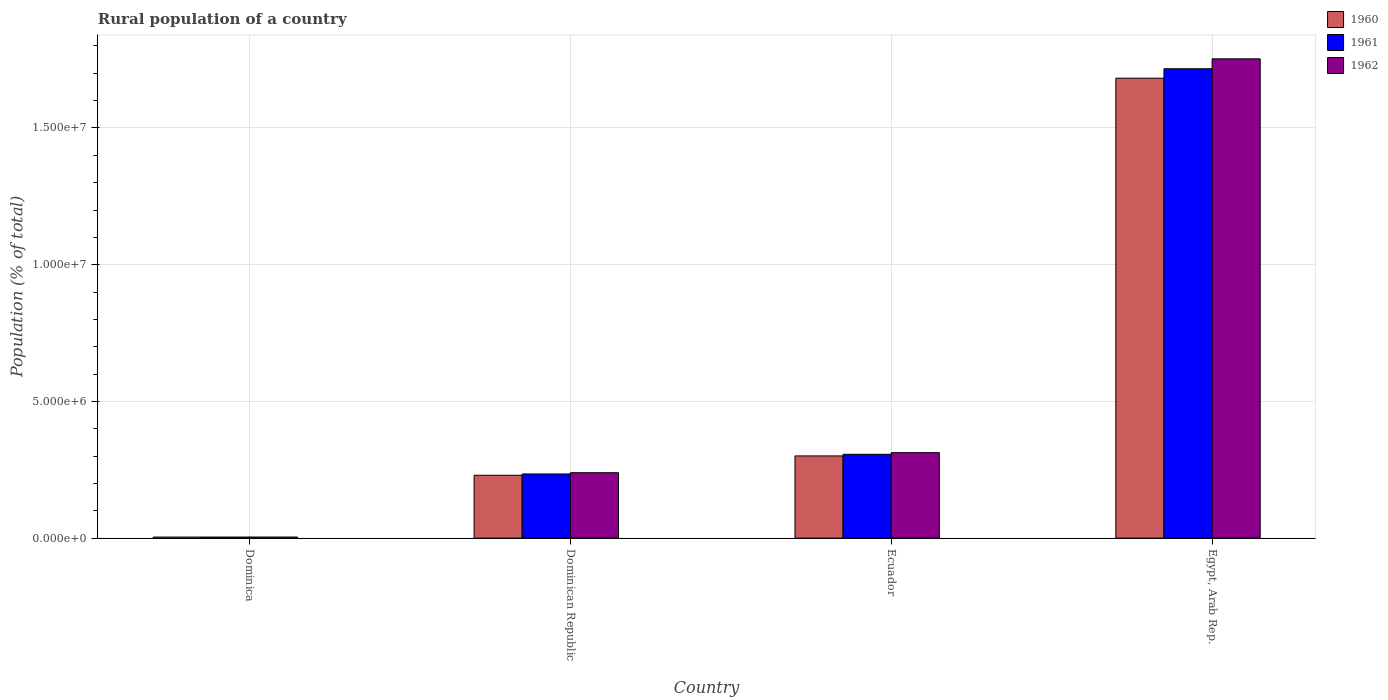How many different coloured bars are there?
Offer a very short reply. 3. How many groups of bars are there?
Keep it short and to the point. 4. Are the number of bars per tick equal to the number of legend labels?
Provide a succinct answer. Yes. What is the label of the 3rd group of bars from the left?
Your response must be concise. Ecuador. In how many cases, is the number of bars for a given country not equal to the number of legend labels?
Your answer should be very brief. 0. What is the rural population in 1962 in Ecuador?
Your response must be concise. 3.13e+06. Across all countries, what is the maximum rural population in 1960?
Offer a very short reply. 1.68e+07. Across all countries, what is the minimum rural population in 1962?
Your answer should be compact. 3.84e+04. In which country was the rural population in 1960 maximum?
Keep it short and to the point. Egypt, Arab Rep. In which country was the rural population in 1961 minimum?
Offer a terse response. Dominica. What is the total rural population in 1960 in the graph?
Give a very brief answer. 2.22e+07. What is the difference between the rural population in 1961 in Dominica and that in Egypt, Arab Rep.?
Your answer should be very brief. -1.71e+07. What is the difference between the rural population in 1962 in Ecuador and the rural population in 1960 in Dominican Republic?
Keep it short and to the point. 8.27e+05. What is the average rural population in 1960 per country?
Keep it short and to the point. 5.54e+06. What is the difference between the rural population of/in 1962 and rural population of/in 1960 in Dominican Republic?
Offer a very short reply. 9.29e+04. What is the ratio of the rural population in 1960 in Ecuador to that in Egypt, Arab Rep.?
Your answer should be very brief. 0.18. What is the difference between the highest and the second highest rural population in 1962?
Provide a short and direct response. 1.44e+07. What is the difference between the highest and the lowest rural population in 1961?
Offer a terse response. 1.71e+07. In how many countries, is the rural population in 1961 greater than the average rural population in 1961 taken over all countries?
Your response must be concise. 1. Is the sum of the rural population in 1962 in Dominica and Egypt, Arab Rep. greater than the maximum rural population in 1960 across all countries?
Offer a terse response. Yes. What does the 2nd bar from the left in Egypt, Arab Rep. represents?
Your answer should be compact. 1961. What does the 3rd bar from the right in Ecuador represents?
Offer a very short reply. 1960. Is it the case that in every country, the sum of the rural population in 1962 and rural population in 1960 is greater than the rural population in 1961?
Provide a succinct answer. Yes. Are the values on the major ticks of Y-axis written in scientific E-notation?
Offer a very short reply. Yes. Does the graph contain any zero values?
Provide a succinct answer. No. Where does the legend appear in the graph?
Provide a short and direct response. Top right. How are the legend labels stacked?
Your answer should be compact. Vertical. What is the title of the graph?
Provide a short and direct response. Rural population of a country. Does "1999" appear as one of the legend labels in the graph?
Make the answer very short. No. What is the label or title of the X-axis?
Offer a terse response. Country. What is the label or title of the Y-axis?
Your answer should be compact. Population (% of total). What is the Population (% of total) of 1960 in Dominica?
Give a very brief answer. 3.73e+04. What is the Population (% of total) of 1961 in Dominica?
Keep it short and to the point. 3.79e+04. What is the Population (% of total) in 1962 in Dominica?
Keep it short and to the point. 3.84e+04. What is the Population (% of total) of 1960 in Dominican Republic?
Give a very brief answer. 2.30e+06. What is the Population (% of total) in 1961 in Dominican Republic?
Offer a very short reply. 2.35e+06. What is the Population (% of total) of 1962 in Dominican Republic?
Keep it short and to the point. 2.39e+06. What is the Population (% of total) of 1960 in Ecuador?
Give a very brief answer. 3.01e+06. What is the Population (% of total) of 1961 in Ecuador?
Provide a succinct answer. 3.06e+06. What is the Population (% of total) in 1962 in Ecuador?
Your response must be concise. 3.13e+06. What is the Population (% of total) in 1960 in Egypt, Arab Rep.?
Make the answer very short. 1.68e+07. What is the Population (% of total) of 1961 in Egypt, Arab Rep.?
Provide a short and direct response. 1.72e+07. What is the Population (% of total) of 1962 in Egypt, Arab Rep.?
Offer a very short reply. 1.75e+07. Across all countries, what is the maximum Population (% of total) of 1960?
Your response must be concise. 1.68e+07. Across all countries, what is the maximum Population (% of total) in 1961?
Give a very brief answer. 1.72e+07. Across all countries, what is the maximum Population (% of total) of 1962?
Your answer should be compact. 1.75e+07. Across all countries, what is the minimum Population (% of total) of 1960?
Keep it short and to the point. 3.73e+04. Across all countries, what is the minimum Population (% of total) of 1961?
Provide a succinct answer. 3.79e+04. Across all countries, what is the minimum Population (% of total) of 1962?
Your response must be concise. 3.84e+04. What is the total Population (% of total) in 1960 in the graph?
Make the answer very short. 2.22e+07. What is the total Population (% of total) of 1961 in the graph?
Keep it short and to the point. 2.26e+07. What is the total Population (% of total) in 1962 in the graph?
Give a very brief answer. 2.31e+07. What is the difference between the Population (% of total) of 1960 in Dominica and that in Dominican Republic?
Offer a terse response. -2.26e+06. What is the difference between the Population (% of total) in 1961 in Dominica and that in Dominican Republic?
Ensure brevity in your answer.  -2.31e+06. What is the difference between the Population (% of total) of 1962 in Dominica and that in Dominican Republic?
Make the answer very short. -2.35e+06. What is the difference between the Population (% of total) in 1960 in Dominica and that in Ecuador?
Offer a very short reply. -2.97e+06. What is the difference between the Population (% of total) of 1961 in Dominica and that in Ecuador?
Keep it short and to the point. -3.03e+06. What is the difference between the Population (% of total) in 1962 in Dominica and that in Ecuador?
Provide a succinct answer. -3.09e+06. What is the difference between the Population (% of total) of 1960 in Dominica and that in Egypt, Arab Rep.?
Your answer should be compact. -1.68e+07. What is the difference between the Population (% of total) in 1961 in Dominica and that in Egypt, Arab Rep.?
Your response must be concise. -1.71e+07. What is the difference between the Population (% of total) of 1962 in Dominica and that in Egypt, Arab Rep.?
Provide a succinct answer. -1.75e+07. What is the difference between the Population (% of total) of 1960 in Dominican Republic and that in Ecuador?
Your response must be concise. -7.07e+05. What is the difference between the Population (% of total) in 1961 in Dominican Republic and that in Ecuador?
Offer a terse response. -7.19e+05. What is the difference between the Population (% of total) in 1962 in Dominican Republic and that in Ecuador?
Provide a short and direct response. -7.34e+05. What is the difference between the Population (% of total) of 1960 in Dominican Republic and that in Egypt, Arab Rep.?
Your response must be concise. -1.45e+07. What is the difference between the Population (% of total) in 1961 in Dominican Republic and that in Egypt, Arab Rep.?
Offer a very short reply. -1.48e+07. What is the difference between the Population (% of total) of 1962 in Dominican Republic and that in Egypt, Arab Rep.?
Offer a very short reply. -1.51e+07. What is the difference between the Population (% of total) in 1960 in Ecuador and that in Egypt, Arab Rep.?
Offer a very short reply. -1.38e+07. What is the difference between the Population (% of total) of 1961 in Ecuador and that in Egypt, Arab Rep.?
Your answer should be very brief. -1.41e+07. What is the difference between the Population (% of total) of 1962 in Ecuador and that in Egypt, Arab Rep.?
Provide a succinct answer. -1.44e+07. What is the difference between the Population (% of total) of 1960 in Dominica and the Population (% of total) of 1961 in Dominican Republic?
Offer a terse response. -2.31e+06. What is the difference between the Population (% of total) of 1960 in Dominica and the Population (% of total) of 1962 in Dominican Republic?
Offer a terse response. -2.35e+06. What is the difference between the Population (% of total) of 1961 in Dominica and the Population (% of total) of 1962 in Dominican Republic?
Provide a succinct answer. -2.35e+06. What is the difference between the Population (% of total) in 1960 in Dominica and the Population (% of total) in 1961 in Ecuador?
Keep it short and to the point. -3.03e+06. What is the difference between the Population (% of total) of 1960 in Dominica and the Population (% of total) of 1962 in Ecuador?
Offer a very short reply. -3.09e+06. What is the difference between the Population (% of total) in 1961 in Dominica and the Population (% of total) in 1962 in Ecuador?
Give a very brief answer. -3.09e+06. What is the difference between the Population (% of total) in 1960 in Dominica and the Population (% of total) in 1961 in Egypt, Arab Rep.?
Make the answer very short. -1.71e+07. What is the difference between the Population (% of total) in 1960 in Dominica and the Population (% of total) in 1962 in Egypt, Arab Rep.?
Provide a succinct answer. -1.75e+07. What is the difference between the Population (% of total) of 1961 in Dominica and the Population (% of total) of 1962 in Egypt, Arab Rep.?
Provide a short and direct response. -1.75e+07. What is the difference between the Population (% of total) of 1960 in Dominican Republic and the Population (% of total) of 1961 in Ecuador?
Your response must be concise. -7.67e+05. What is the difference between the Population (% of total) in 1960 in Dominican Republic and the Population (% of total) in 1962 in Ecuador?
Your answer should be compact. -8.27e+05. What is the difference between the Population (% of total) of 1961 in Dominican Republic and the Population (% of total) of 1962 in Ecuador?
Keep it short and to the point. -7.80e+05. What is the difference between the Population (% of total) in 1960 in Dominican Republic and the Population (% of total) in 1961 in Egypt, Arab Rep.?
Keep it short and to the point. -1.49e+07. What is the difference between the Population (% of total) of 1960 in Dominican Republic and the Population (% of total) of 1962 in Egypt, Arab Rep.?
Make the answer very short. -1.52e+07. What is the difference between the Population (% of total) of 1961 in Dominican Republic and the Population (% of total) of 1962 in Egypt, Arab Rep.?
Provide a succinct answer. -1.52e+07. What is the difference between the Population (% of total) of 1960 in Ecuador and the Population (% of total) of 1961 in Egypt, Arab Rep.?
Give a very brief answer. -1.42e+07. What is the difference between the Population (% of total) of 1960 in Ecuador and the Population (% of total) of 1962 in Egypt, Arab Rep.?
Offer a very short reply. -1.45e+07. What is the difference between the Population (% of total) of 1961 in Ecuador and the Population (% of total) of 1962 in Egypt, Arab Rep.?
Make the answer very short. -1.45e+07. What is the average Population (% of total) in 1960 per country?
Make the answer very short. 5.54e+06. What is the average Population (% of total) of 1961 per country?
Provide a short and direct response. 5.65e+06. What is the average Population (% of total) in 1962 per country?
Offer a very short reply. 5.77e+06. What is the difference between the Population (% of total) in 1960 and Population (% of total) in 1961 in Dominica?
Your answer should be compact. -593. What is the difference between the Population (% of total) in 1960 and Population (% of total) in 1962 in Dominica?
Your answer should be very brief. -1141. What is the difference between the Population (% of total) in 1961 and Population (% of total) in 1962 in Dominica?
Your response must be concise. -548. What is the difference between the Population (% of total) in 1960 and Population (% of total) in 1961 in Dominican Republic?
Offer a very short reply. -4.73e+04. What is the difference between the Population (% of total) of 1960 and Population (% of total) of 1962 in Dominican Republic?
Ensure brevity in your answer.  -9.29e+04. What is the difference between the Population (% of total) in 1961 and Population (% of total) in 1962 in Dominican Republic?
Offer a terse response. -4.56e+04. What is the difference between the Population (% of total) of 1960 and Population (% of total) of 1961 in Ecuador?
Offer a very short reply. -5.93e+04. What is the difference between the Population (% of total) of 1960 and Population (% of total) of 1962 in Ecuador?
Make the answer very short. -1.20e+05. What is the difference between the Population (% of total) of 1961 and Population (% of total) of 1962 in Ecuador?
Your answer should be very brief. -6.06e+04. What is the difference between the Population (% of total) of 1960 and Population (% of total) of 1961 in Egypt, Arab Rep.?
Your answer should be compact. -3.45e+05. What is the difference between the Population (% of total) of 1960 and Population (% of total) of 1962 in Egypt, Arab Rep.?
Offer a terse response. -7.08e+05. What is the difference between the Population (% of total) of 1961 and Population (% of total) of 1962 in Egypt, Arab Rep.?
Make the answer very short. -3.63e+05. What is the ratio of the Population (% of total) in 1960 in Dominica to that in Dominican Republic?
Your answer should be very brief. 0.02. What is the ratio of the Population (% of total) of 1961 in Dominica to that in Dominican Republic?
Offer a very short reply. 0.02. What is the ratio of the Population (% of total) in 1962 in Dominica to that in Dominican Republic?
Ensure brevity in your answer.  0.02. What is the ratio of the Population (% of total) in 1960 in Dominica to that in Ecuador?
Your response must be concise. 0.01. What is the ratio of the Population (% of total) of 1961 in Dominica to that in Ecuador?
Offer a very short reply. 0.01. What is the ratio of the Population (% of total) in 1962 in Dominica to that in Ecuador?
Provide a short and direct response. 0.01. What is the ratio of the Population (% of total) of 1960 in Dominica to that in Egypt, Arab Rep.?
Your answer should be very brief. 0. What is the ratio of the Population (% of total) in 1961 in Dominica to that in Egypt, Arab Rep.?
Keep it short and to the point. 0. What is the ratio of the Population (% of total) in 1962 in Dominica to that in Egypt, Arab Rep.?
Your answer should be compact. 0. What is the ratio of the Population (% of total) of 1960 in Dominican Republic to that in Ecuador?
Your answer should be compact. 0.76. What is the ratio of the Population (% of total) in 1961 in Dominican Republic to that in Ecuador?
Offer a terse response. 0.77. What is the ratio of the Population (% of total) in 1962 in Dominican Republic to that in Ecuador?
Provide a short and direct response. 0.77. What is the ratio of the Population (% of total) of 1960 in Dominican Republic to that in Egypt, Arab Rep.?
Provide a succinct answer. 0.14. What is the ratio of the Population (% of total) in 1961 in Dominican Republic to that in Egypt, Arab Rep.?
Your answer should be compact. 0.14. What is the ratio of the Population (% of total) of 1962 in Dominican Republic to that in Egypt, Arab Rep.?
Give a very brief answer. 0.14. What is the ratio of the Population (% of total) of 1960 in Ecuador to that in Egypt, Arab Rep.?
Your answer should be very brief. 0.18. What is the ratio of the Population (% of total) in 1961 in Ecuador to that in Egypt, Arab Rep.?
Make the answer very short. 0.18. What is the ratio of the Population (% of total) of 1962 in Ecuador to that in Egypt, Arab Rep.?
Your answer should be compact. 0.18. What is the difference between the highest and the second highest Population (% of total) in 1960?
Your answer should be very brief. 1.38e+07. What is the difference between the highest and the second highest Population (% of total) of 1961?
Your response must be concise. 1.41e+07. What is the difference between the highest and the second highest Population (% of total) in 1962?
Your answer should be compact. 1.44e+07. What is the difference between the highest and the lowest Population (% of total) of 1960?
Offer a terse response. 1.68e+07. What is the difference between the highest and the lowest Population (% of total) of 1961?
Provide a short and direct response. 1.71e+07. What is the difference between the highest and the lowest Population (% of total) in 1962?
Provide a succinct answer. 1.75e+07. 